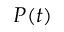<formula> <loc_0><loc_0><loc_500><loc_500>P ( t )</formula> 